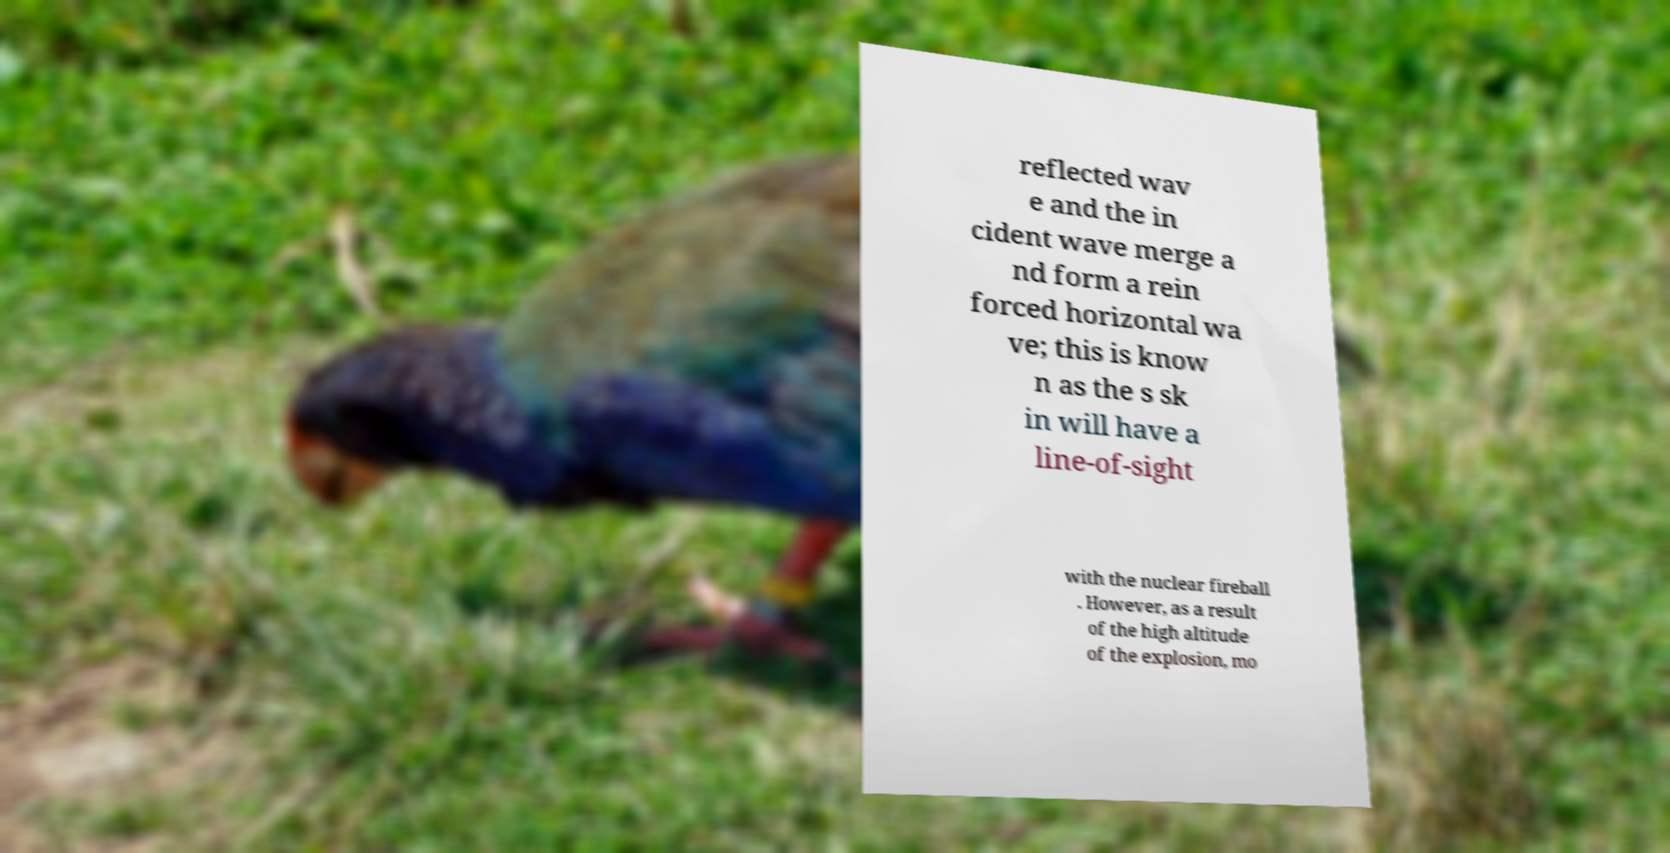Please identify and transcribe the text found in this image. reflected wav e and the in cident wave merge a nd form a rein forced horizontal wa ve; this is know n as the s sk in will have a line-of-sight with the nuclear fireball . However, as a result of the high altitude of the explosion, mo 